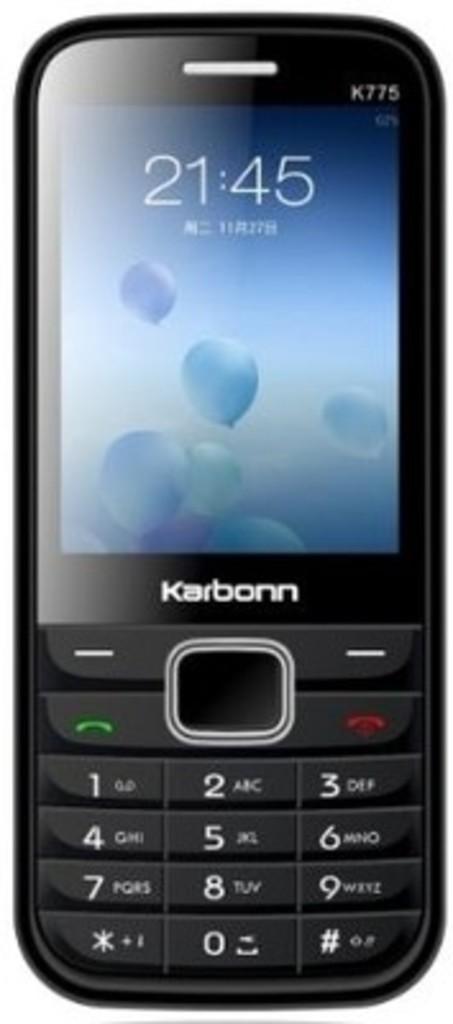What is the phone model?
Provide a short and direct response. K775. What time is the clock showing?
Provide a succinct answer. 21:45. 